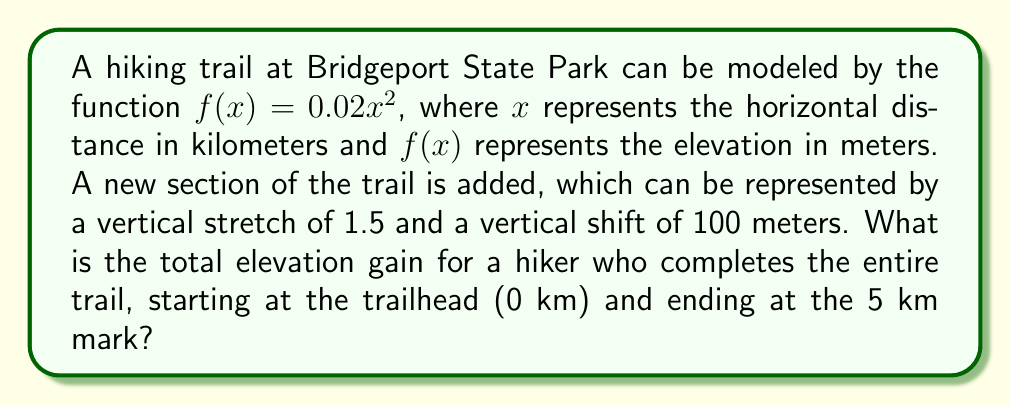Can you answer this question? To solve this problem, we need to follow these steps:

1) The new trail section is represented by a vertical stretch and shift of the original function. The new function $g(x)$ can be written as:

   $g(x) = 1.5f(x) + 100$

2) Substituting the original function:

   $g(x) = 1.5(0.02x^2) + 100$
   $g(x) = 0.03x^2 + 100$

3) To find the elevation gain, we need to calculate the difference between the highest and lowest points on the trail.

4) The lowest point is at the trailhead (x = 0):

   $g(0) = 0.03(0)^2 + 100 = 100$ meters

5) The highest point is at the end of the trail (x = 5):

   $g(5) = 0.03(5)^2 + 100 = 0.03(25) + 100 = 0.75 + 100 = 100.75$ meters

6) The elevation gain is the difference between these two points:

   Elevation gain = $100.75 - 100 = 0.75$ meters
Answer: The total elevation gain for the hiker is 0.75 meters. 